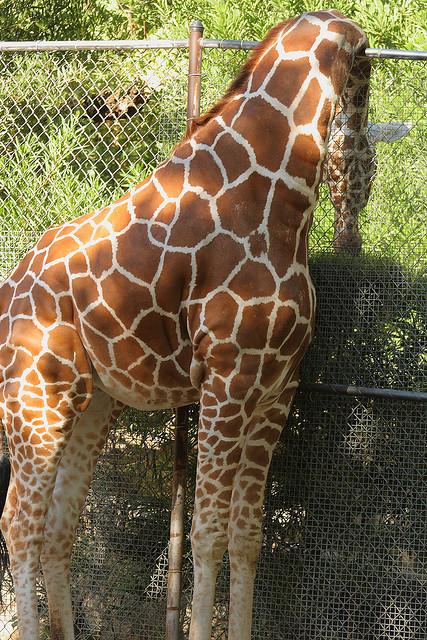Is the fence effective?
Concise answer only. Yes. What is this animal?
Be succinct. Giraffe. What is this giraffe eating?
Be succinct. Leaves. What is this animal doing?
Short answer required. Eating. 